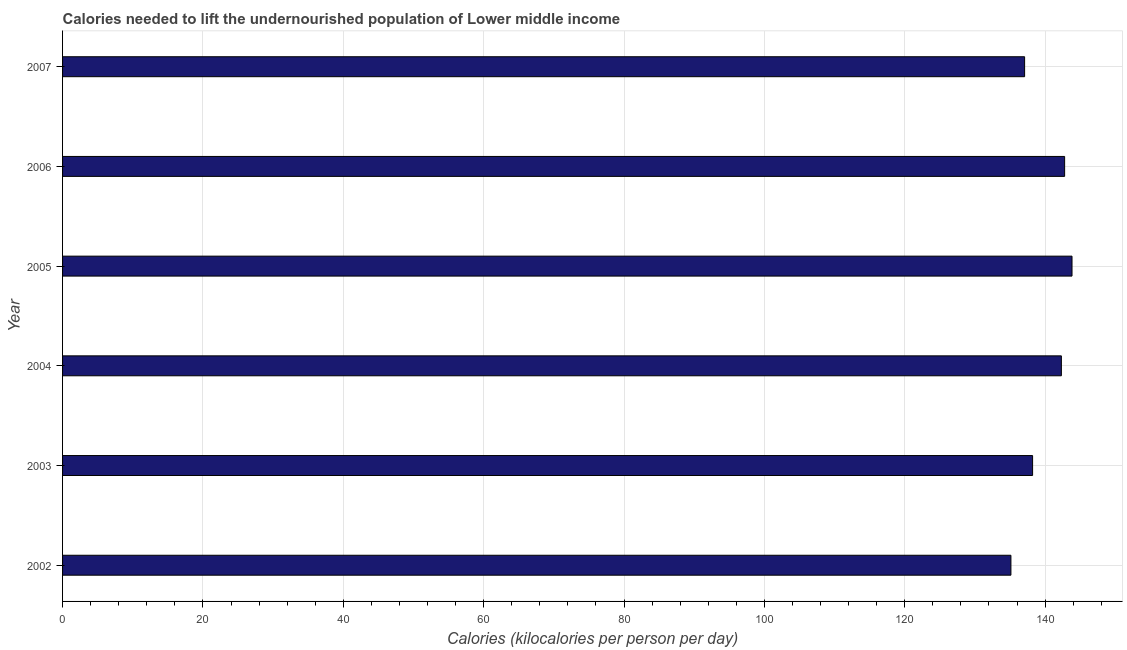Does the graph contain any zero values?
Offer a terse response. No. What is the title of the graph?
Your answer should be very brief. Calories needed to lift the undernourished population of Lower middle income. What is the label or title of the X-axis?
Provide a succinct answer. Calories (kilocalories per person per day). What is the depth of food deficit in 2007?
Ensure brevity in your answer.  137.08. Across all years, what is the maximum depth of food deficit?
Offer a very short reply. 143.83. Across all years, what is the minimum depth of food deficit?
Offer a terse response. 135.13. In which year was the depth of food deficit maximum?
Ensure brevity in your answer.  2005. In which year was the depth of food deficit minimum?
Keep it short and to the point. 2002. What is the sum of the depth of food deficit?
Make the answer very short. 839.36. What is the difference between the depth of food deficit in 2002 and 2006?
Ensure brevity in your answer.  -7.65. What is the average depth of food deficit per year?
Give a very brief answer. 139.89. What is the median depth of food deficit?
Your answer should be compact. 140.27. Is the depth of food deficit in 2005 less than that in 2006?
Provide a short and direct response. No. What is the difference between the highest and the second highest depth of food deficit?
Your answer should be very brief. 1.05. Is the sum of the depth of food deficit in 2004 and 2007 greater than the maximum depth of food deficit across all years?
Offer a very short reply. Yes. What is the difference between the highest and the lowest depth of food deficit?
Offer a very short reply. 8.71. In how many years, is the depth of food deficit greater than the average depth of food deficit taken over all years?
Keep it short and to the point. 3. How many bars are there?
Offer a terse response. 6. Are all the bars in the graph horizontal?
Ensure brevity in your answer.  Yes. How many years are there in the graph?
Offer a very short reply. 6. What is the difference between two consecutive major ticks on the X-axis?
Ensure brevity in your answer.  20. What is the Calories (kilocalories per person per day) in 2002?
Ensure brevity in your answer.  135.13. What is the Calories (kilocalories per person per day) in 2003?
Ensure brevity in your answer.  138.22. What is the Calories (kilocalories per person per day) in 2004?
Provide a short and direct response. 142.32. What is the Calories (kilocalories per person per day) of 2005?
Make the answer very short. 143.83. What is the Calories (kilocalories per person per day) in 2006?
Provide a succinct answer. 142.78. What is the Calories (kilocalories per person per day) in 2007?
Make the answer very short. 137.08. What is the difference between the Calories (kilocalories per person per day) in 2002 and 2003?
Provide a succinct answer. -3.09. What is the difference between the Calories (kilocalories per person per day) in 2002 and 2004?
Provide a succinct answer. -7.19. What is the difference between the Calories (kilocalories per person per day) in 2002 and 2005?
Your answer should be very brief. -8.71. What is the difference between the Calories (kilocalories per person per day) in 2002 and 2006?
Your answer should be compact. -7.65. What is the difference between the Calories (kilocalories per person per day) in 2002 and 2007?
Keep it short and to the point. -1.95. What is the difference between the Calories (kilocalories per person per day) in 2003 and 2004?
Provide a succinct answer. -4.1. What is the difference between the Calories (kilocalories per person per day) in 2003 and 2005?
Offer a very short reply. -5.62. What is the difference between the Calories (kilocalories per person per day) in 2003 and 2006?
Offer a very short reply. -4.56. What is the difference between the Calories (kilocalories per person per day) in 2003 and 2007?
Your answer should be very brief. 1.14. What is the difference between the Calories (kilocalories per person per day) in 2004 and 2005?
Your response must be concise. -1.52. What is the difference between the Calories (kilocalories per person per day) in 2004 and 2006?
Provide a short and direct response. -0.46. What is the difference between the Calories (kilocalories per person per day) in 2004 and 2007?
Your answer should be compact. 5.24. What is the difference between the Calories (kilocalories per person per day) in 2005 and 2006?
Offer a very short reply. 1.05. What is the difference between the Calories (kilocalories per person per day) in 2005 and 2007?
Provide a succinct answer. 6.75. What is the difference between the Calories (kilocalories per person per day) in 2006 and 2007?
Provide a short and direct response. 5.7. What is the ratio of the Calories (kilocalories per person per day) in 2002 to that in 2003?
Your answer should be compact. 0.98. What is the ratio of the Calories (kilocalories per person per day) in 2002 to that in 2004?
Your answer should be compact. 0.95. What is the ratio of the Calories (kilocalories per person per day) in 2002 to that in 2005?
Give a very brief answer. 0.94. What is the ratio of the Calories (kilocalories per person per day) in 2002 to that in 2006?
Keep it short and to the point. 0.95. What is the ratio of the Calories (kilocalories per person per day) in 2003 to that in 2004?
Your response must be concise. 0.97. What is the ratio of the Calories (kilocalories per person per day) in 2003 to that in 2005?
Keep it short and to the point. 0.96. What is the ratio of the Calories (kilocalories per person per day) in 2003 to that in 2007?
Ensure brevity in your answer.  1.01. What is the ratio of the Calories (kilocalories per person per day) in 2004 to that in 2007?
Offer a terse response. 1.04. What is the ratio of the Calories (kilocalories per person per day) in 2005 to that in 2006?
Ensure brevity in your answer.  1.01. What is the ratio of the Calories (kilocalories per person per day) in 2005 to that in 2007?
Offer a very short reply. 1.05. What is the ratio of the Calories (kilocalories per person per day) in 2006 to that in 2007?
Your answer should be very brief. 1.04. 